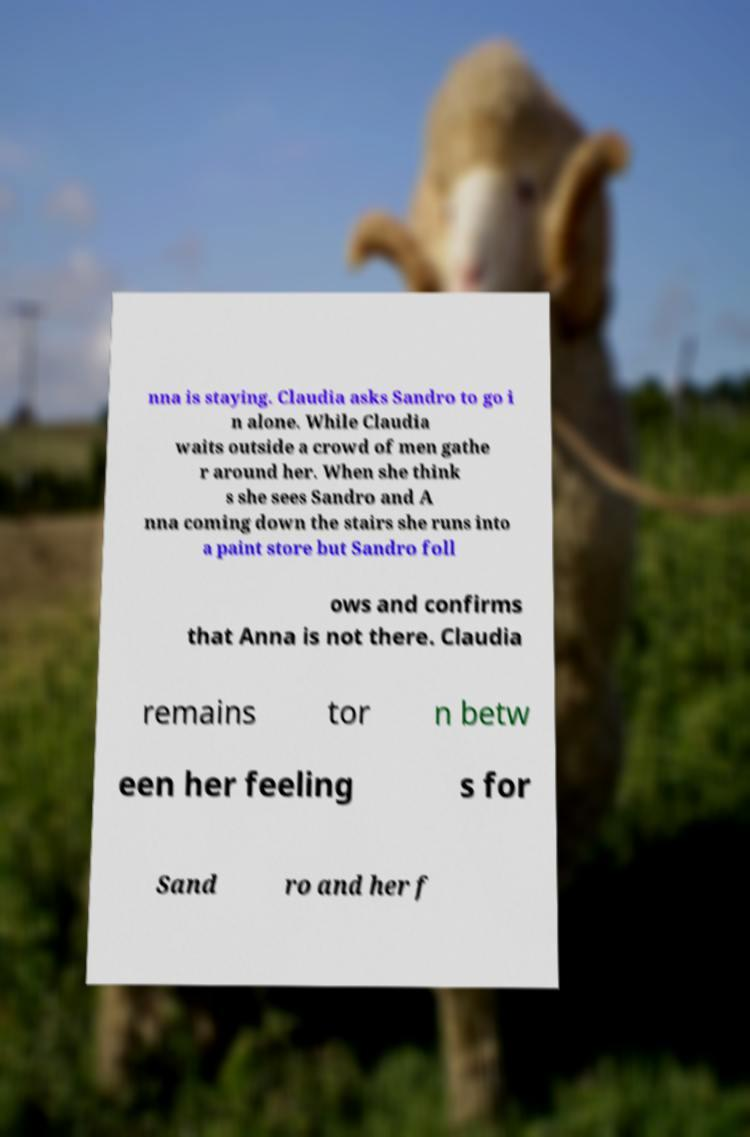What messages or text are displayed in this image? I need them in a readable, typed format. nna is staying. Claudia asks Sandro to go i n alone. While Claudia waits outside a crowd of men gathe r around her. When she think s she sees Sandro and A nna coming down the stairs she runs into a paint store but Sandro foll ows and confirms that Anna is not there. Claudia remains tor n betw een her feeling s for Sand ro and her f 